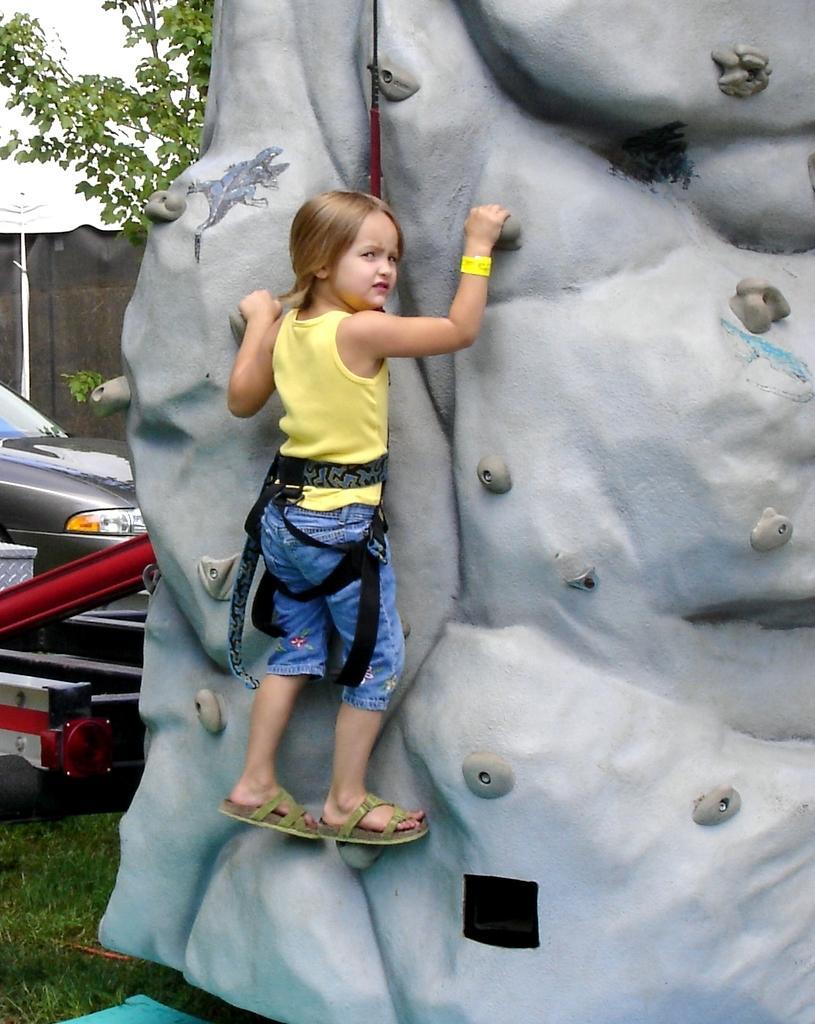Please provide a concise description of this image. In this image we can see a child doing rock climbing. In the background there are trees, walls, motor vehicle and grass. 